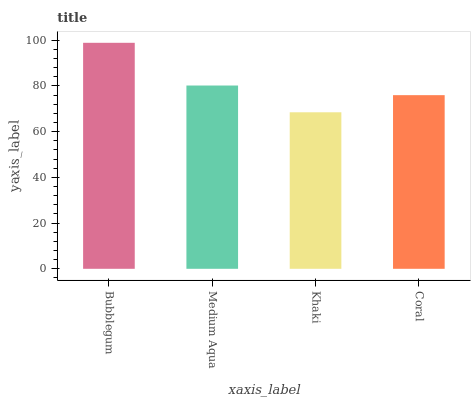Is Khaki the minimum?
Answer yes or no. Yes. Is Bubblegum the maximum?
Answer yes or no. Yes. Is Medium Aqua the minimum?
Answer yes or no. No. Is Medium Aqua the maximum?
Answer yes or no. No. Is Bubblegum greater than Medium Aqua?
Answer yes or no. Yes. Is Medium Aqua less than Bubblegum?
Answer yes or no. Yes. Is Medium Aqua greater than Bubblegum?
Answer yes or no. No. Is Bubblegum less than Medium Aqua?
Answer yes or no. No. Is Medium Aqua the high median?
Answer yes or no. Yes. Is Coral the low median?
Answer yes or no. Yes. Is Coral the high median?
Answer yes or no. No. Is Medium Aqua the low median?
Answer yes or no. No. 